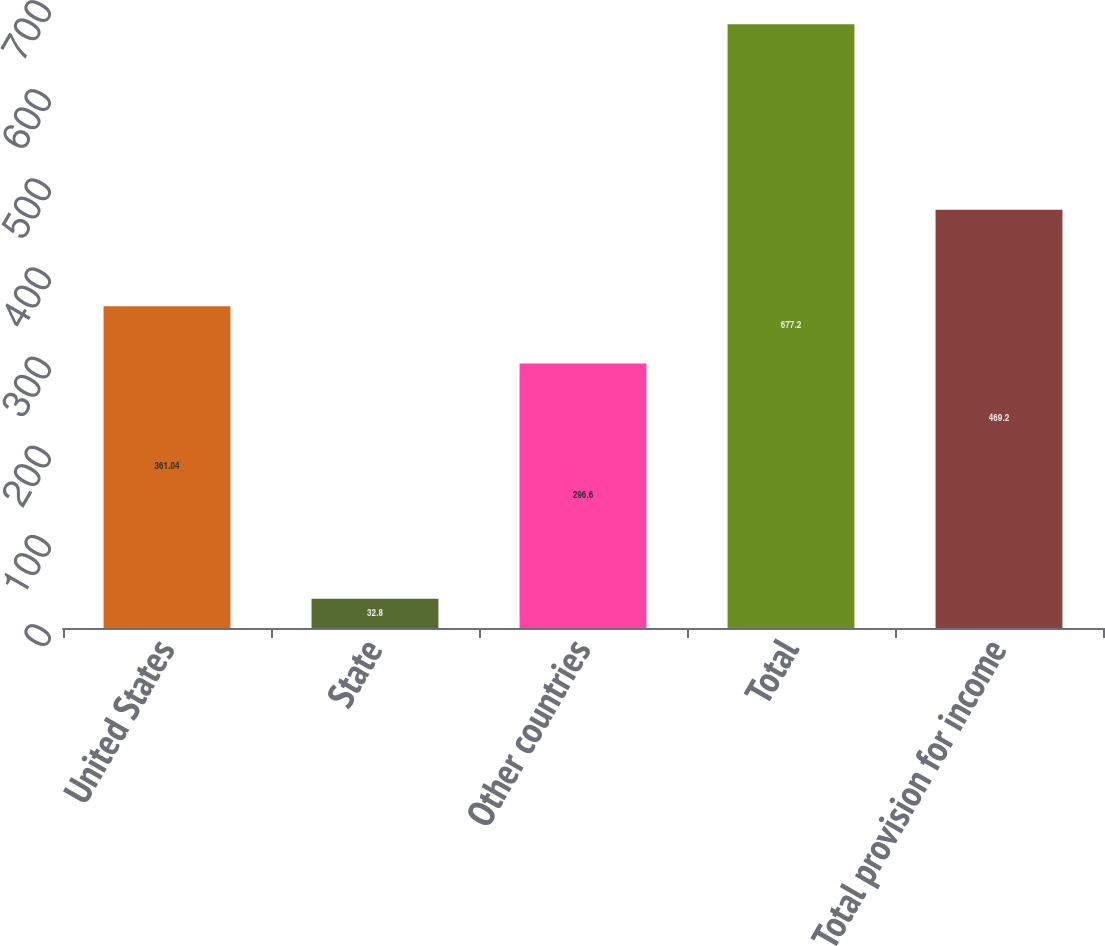Convert chart to OTSL. <chart><loc_0><loc_0><loc_500><loc_500><bar_chart><fcel>United States<fcel>State<fcel>Other countries<fcel>Total<fcel>Total provision for income<nl><fcel>361.04<fcel>32.8<fcel>296.6<fcel>677.2<fcel>469.2<nl></chart> 